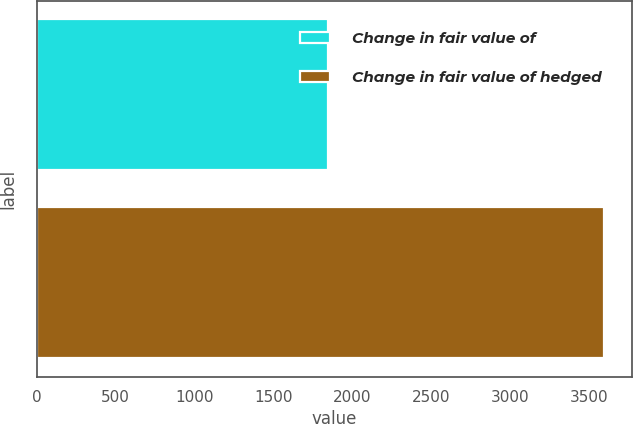Convert chart. <chart><loc_0><loc_0><loc_500><loc_500><bar_chart><fcel>Change in fair value of<fcel>Change in fair value of hedged<nl><fcel>1847<fcel>3594.2<nl></chart> 